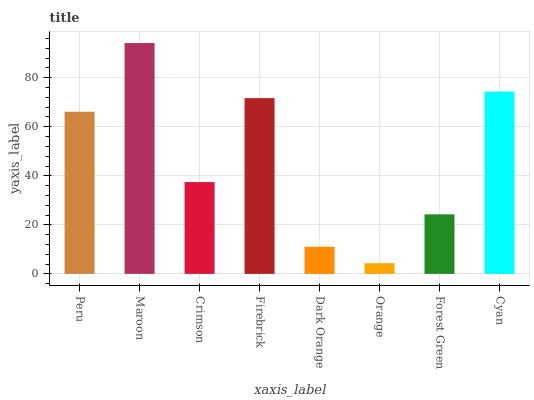Is Orange the minimum?
Answer yes or no. Yes. Is Maroon the maximum?
Answer yes or no. Yes. Is Crimson the minimum?
Answer yes or no. No. Is Crimson the maximum?
Answer yes or no. No. Is Maroon greater than Crimson?
Answer yes or no. Yes. Is Crimson less than Maroon?
Answer yes or no. Yes. Is Crimson greater than Maroon?
Answer yes or no. No. Is Maroon less than Crimson?
Answer yes or no. No. Is Peru the high median?
Answer yes or no. Yes. Is Crimson the low median?
Answer yes or no. Yes. Is Forest Green the high median?
Answer yes or no. No. Is Orange the low median?
Answer yes or no. No. 